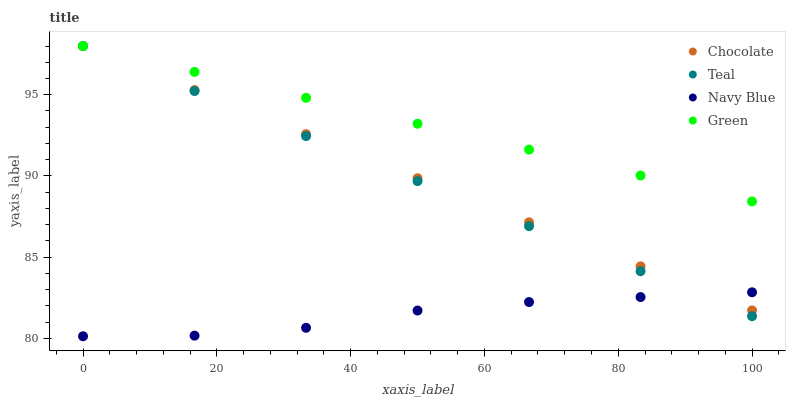Does Navy Blue have the minimum area under the curve?
Answer yes or no. Yes. Does Green have the maximum area under the curve?
Answer yes or no. Yes. Does Teal have the minimum area under the curve?
Answer yes or no. No. Does Teal have the maximum area under the curve?
Answer yes or no. No. Is Green the smoothest?
Answer yes or no. Yes. Is Navy Blue the roughest?
Answer yes or no. Yes. Is Teal the smoothest?
Answer yes or no. No. Is Teal the roughest?
Answer yes or no. No. Does Navy Blue have the lowest value?
Answer yes or no. Yes. Does Teal have the lowest value?
Answer yes or no. No. Does Chocolate have the highest value?
Answer yes or no. Yes. Is Navy Blue less than Green?
Answer yes or no. Yes. Is Green greater than Navy Blue?
Answer yes or no. Yes. Does Chocolate intersect Navy Blue?
Answer yes or no. Yes. Is Chocolate less than Navy Blue?
Answer yes or no. No. Is Chocolate greater than Navy Blue?
Answer yes or no. No. Does Navy Blue intersect Green?
Answer yes or no. No. 